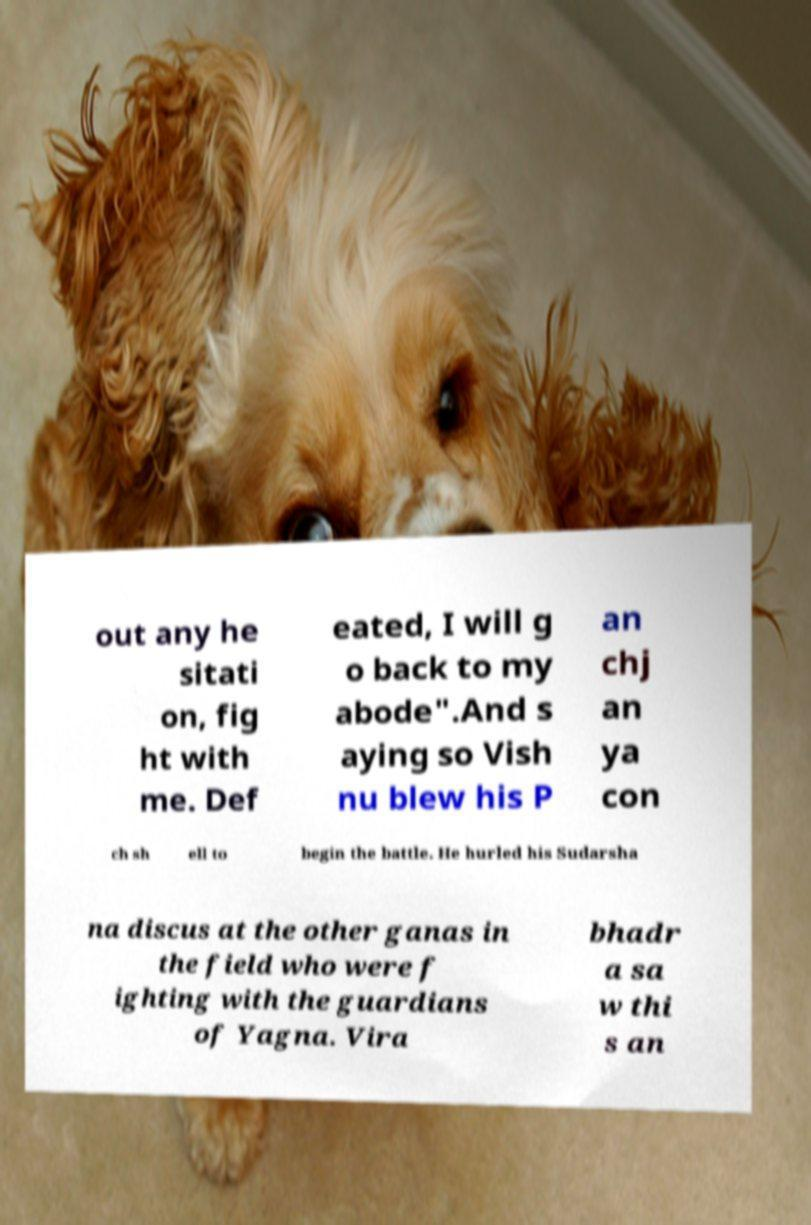Can you accurately transcribe the text from the provided image for me? out any he sitati on, fig ht with me. Def eated, I will g o back to my abode".And s aying so Vish nu blew his P an chj an ya con ch sh ell to begin the battle. He hurled his Sudarsha na discus at the other ganas in the field who were f ighting with the guardians of Yagna. Vira bhadr a sa w thi s an 